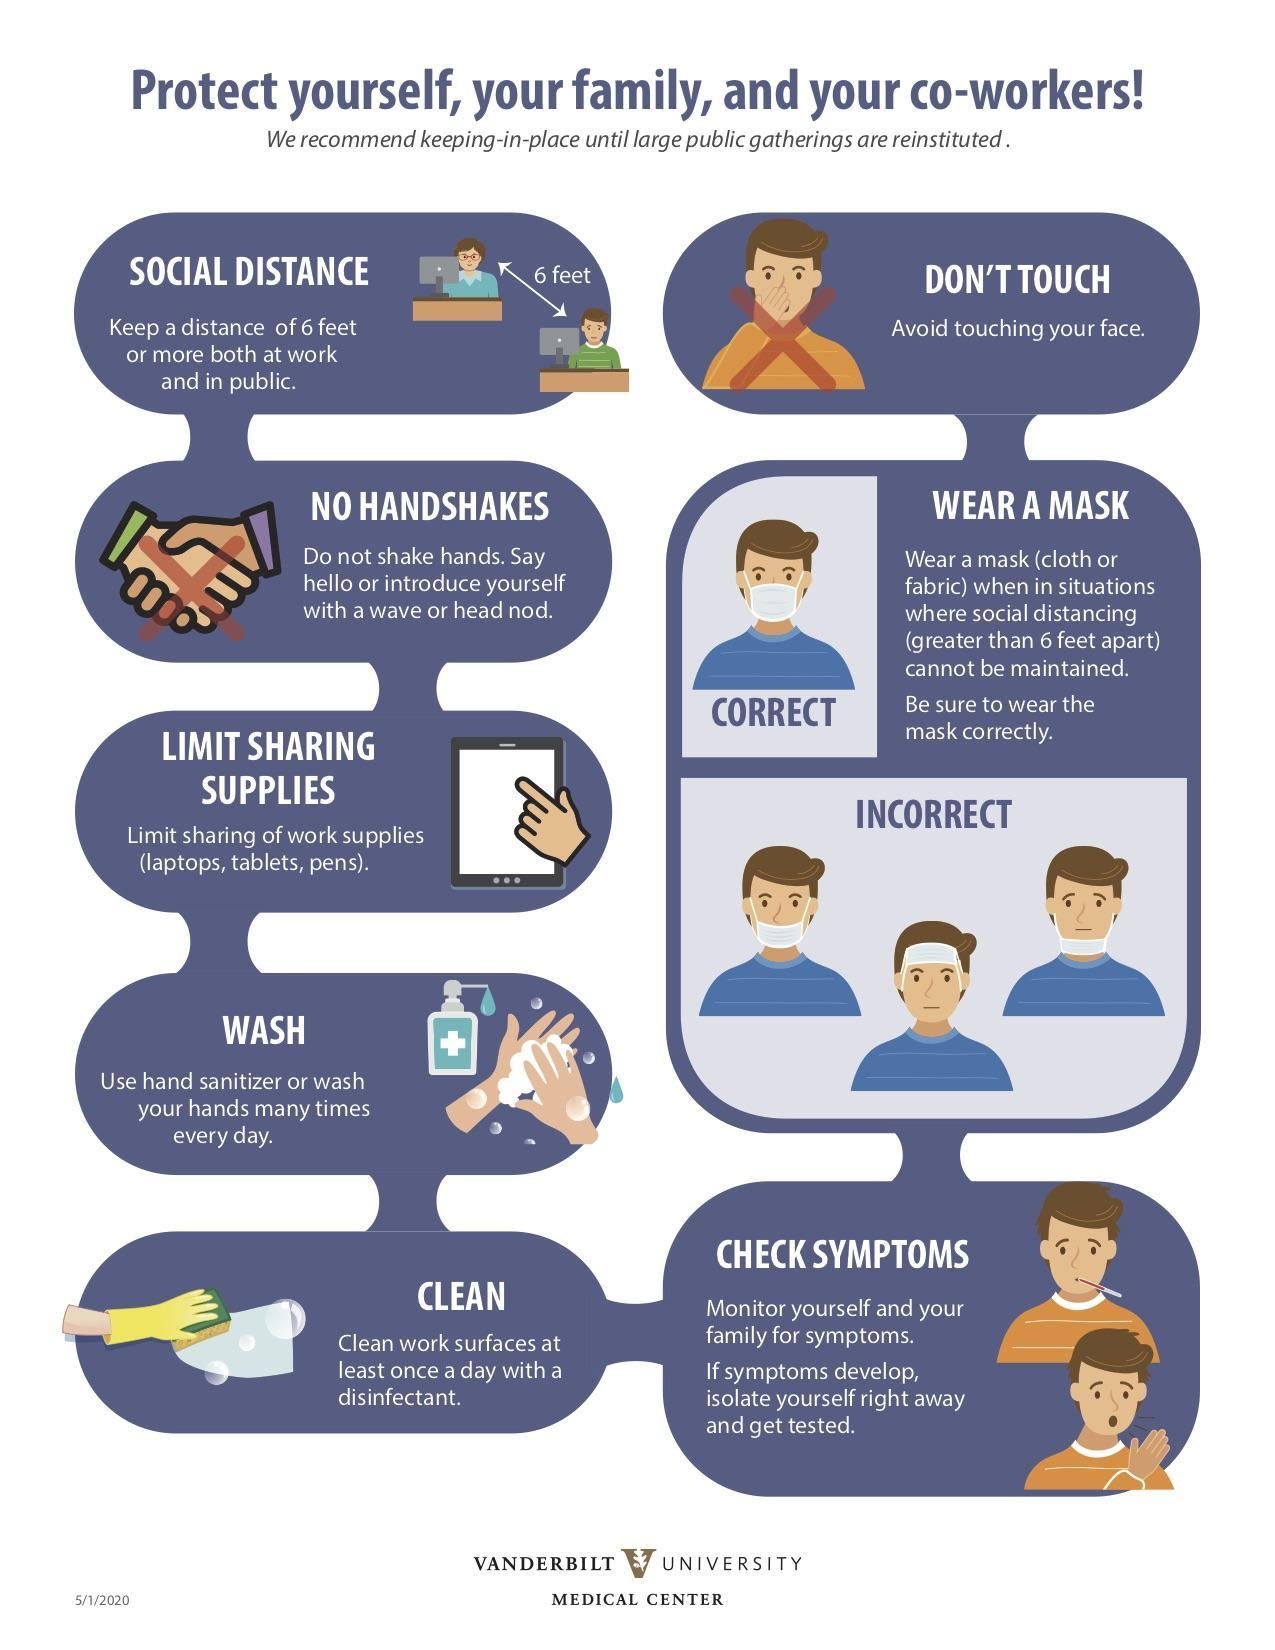what is the third prevention measure given at the right side?
Answer the question with a short phrase. check symptoms what is the second prevention measure given at the left side? no handshakes what is the second prevention measure given at the right side? wear a mask How many prevention measures are given in this infographic? 8 what is the fourth prevention measure given at the left side? wash what is the third prevention measure given at the left side? limit sharing supplies 